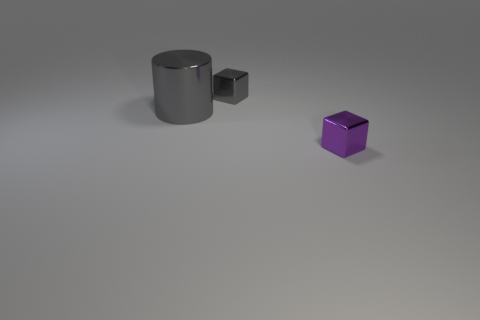Add 1 large green metal objects. How many objects exist? 4 Subtract all cylinders. How many objects are left? 2 Subtract 0 blue cylinders. How many objects are left? 3 Subtract all gray things. Subtract all gray rubber cylinders. How many objects are left? 1 Add 1 small purple metallic blocks. How many small purple metallic blocks are left? 2 Add 3 gray objects. How many gray objects exist? 5 